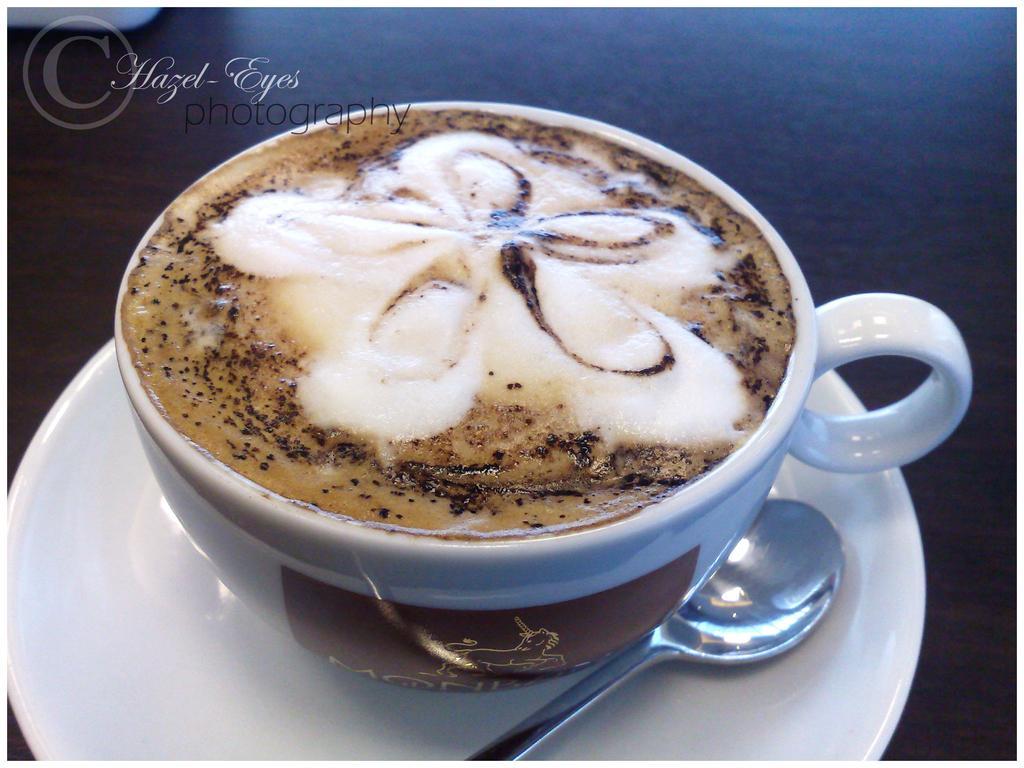Could you give a brief overview of what you see in this image? In the center of the image we can see a saucer, cup and spoon. In the cup, we can see coffee. At the top left side of the image, there is a watermark and one white color object. And we can see the dark background. 